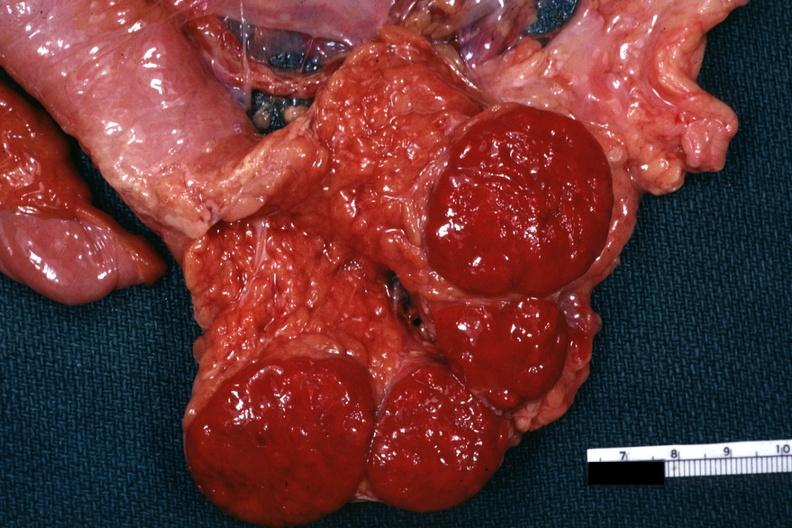does this image show tail of pancreas with spleens?
Answer the question using a single word or phrase. Yes 